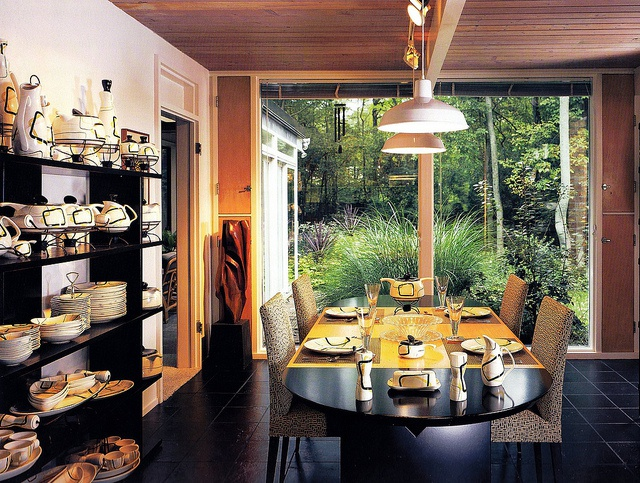Describe the objects in this image and their specific colors. I can see dining table in lightgray, black, gray, ivory, and orange tones, chair in lightgray, black, gray, and tan tones, chair in lightgray, black, gray, and tan tones, cup in lightgray, white, gray, and black tones, and chair in lightgray, brown, maroon, and black tones in this image. 